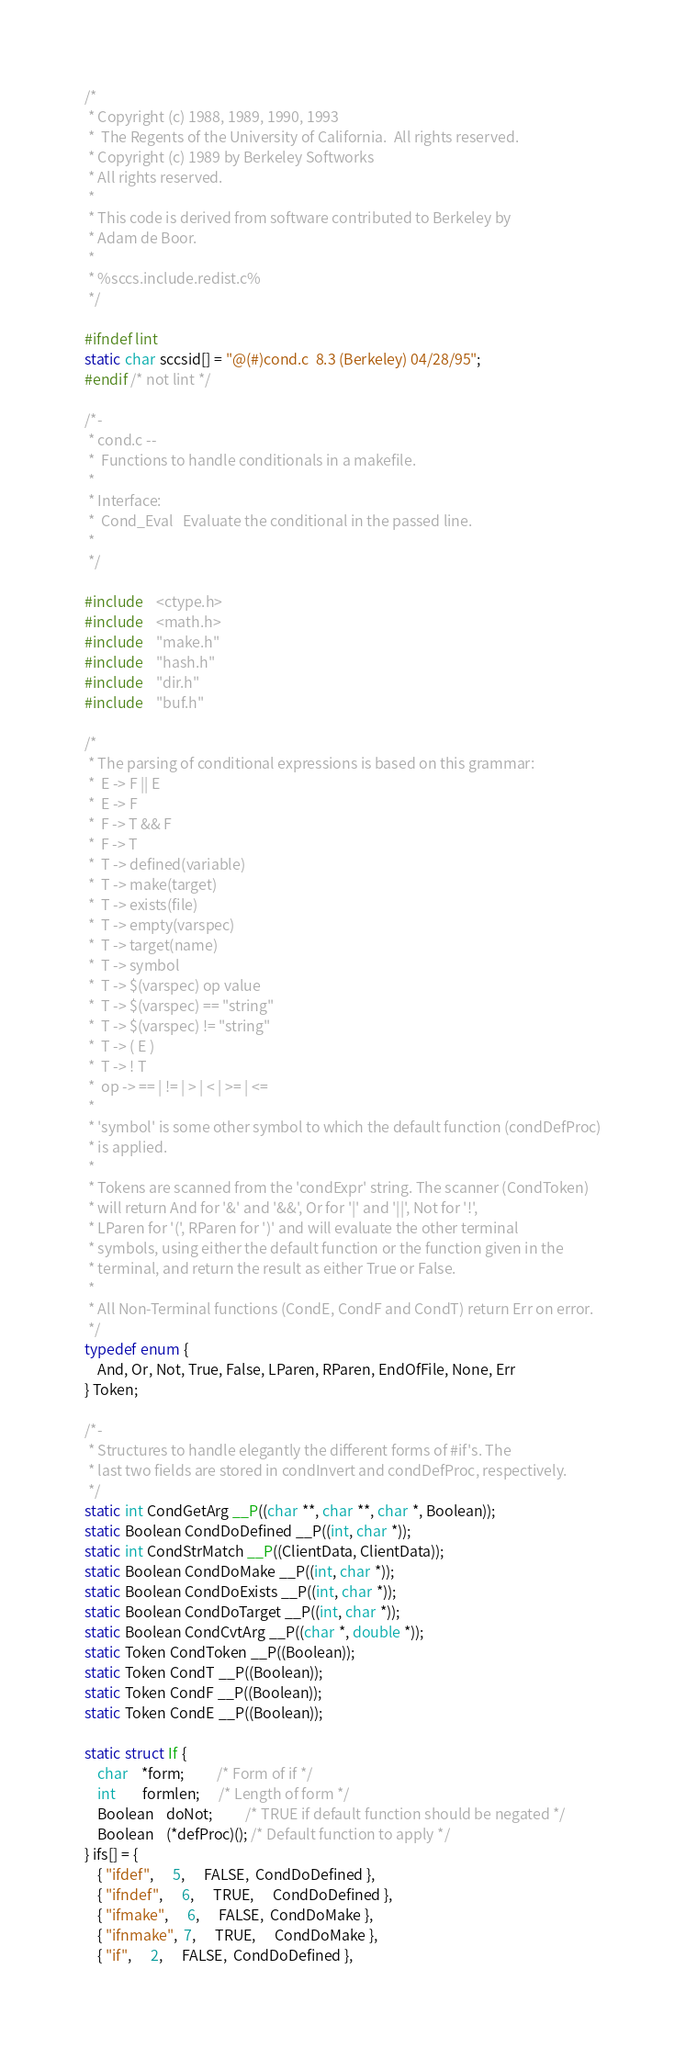Convert code to text. <code><loc_0><loc_0><loc_500><loc_500><_C_>/*
 * Copyright (c) 1988, 1989, 1990, 1993
 *	The Regents of the University of California.  All rights reserved.
 * Copyright (c) 1989 by Berkeley Softworks
 * All rights reserved.
 *
 * This code is derived from software contributed to Berkeley by
 * Adam de Boor.
 *
 * %sccs.include.redist.c%
 */

#ifndef lint
static char sccsid[] = "@(#)cond.c	8.3 (Berkeley) 04/28/95";
#endif /* not lint */

/*-
 * cond.c --
 *	Functions to handle conditionals in a makefile.
 *
 * Interface:
 *	Cond_Eval 	Evaluate the conditional in the passed line.
 *
 */

#include    <ctype.h>
#include    <math.h>
#include    "make.h"
#include    "hash.h"
#include    "dir.h"
#include    "buf.h"

/*
 * The parsing of conditional expressions is based on this grammar:
 *	E -> F || E
 *	E -> F
 *	F -> T && F
 *	F -> T
 *	T -> defined(variable)
 *	T -> make(target)
 *	T -> exists(file)
 *	T -> empty(varspec)
 *	T -> target(name)
 *	T -> symbol
 *	T -> $(varspec) op value
 *	T -> $(varspec) == "string"
 *	T -> $(varspec) != "string"
 *	T -> ( E )
 *	T -> ! T
 *	op -> == | != | > | < | >= | <=
 *
 * 'symbol' is some other symbol to which the default function (condDefProc)
 * is applied.
 *
 * Tokens are scanned from the 'condExpr' string. The scanner (CondToken)
 * will return And for '&' and '&&', Or for '|' and '||', Not for '!',
 * LParen for '(', RParen for ')' and will evaluate the other terminal
 * symbols, using either the default function or the function given in the
 * terminal, and return the result as either True or False.
 *
 * All Non-Terminal functions (CondE, CondF and CondT) return Err on error.
 */
typedef enum {
    And, Or, Not, True, False, LParen, RParen, EndOfFile, None, Err
} Token;

/*-
 * Structures to handle elegantly the different forms of #if's. The
 * last two fields are stored in condInvert and condDefProc, respectively.
 */
static int CondGetArg __P((char **, char **, char *, Boolean));
static Boolean CondDoDefined __P((int, char *));
static int CondStrMatch __P((ClientData, ClientData));
static Boolean CondDoMake __P((int, char *));
static Boolean CondDoExists __P((int, char *));
static Boolean CondDoTarget __P((int, char *));
static Boolean CondCvtArg __P((char *, double *));
static Token CondToken __P((Boolean));
static Token CondT __P((Boolean));
static Token CondF __P((Boolean));
static Token CondE __P((Boolean));

static struct If {
    char	*form;	      /* Form of if */
    int		formlen;      /* Length of form */
    Boolean	doNot;	      /* TRUE if default function should be negated */
    Boolean	(*defProc)(); /* Default function to apply */
} ifs[] = {
    { "ifdef",	  5,	  FALSE,  CondDoDefined },
    { "ifndef",	  6,	  TRUE,	  CondDoDefined },
    { "ifmake",	  6,	  FALSE,  CondDoMake },
    { "ifnmake",  7,	  TRUE,	  CondDoMake },
    { "if",	  2,	  FALSE,  CondDoDefined },</code> 